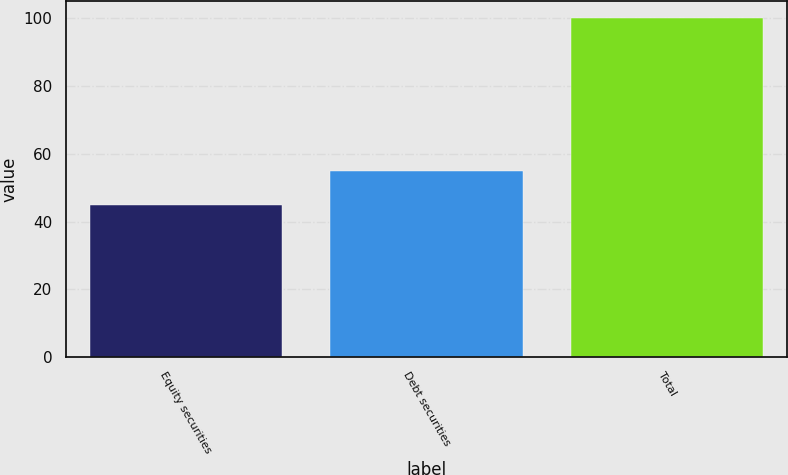<chart> <loc_0><loc_0><loc_500><loc_500><bar_chart><fcel>Equity securities<fcel>Debt securities<fcel>Total<nl><fcel>45<fcel>55<fcel>100<nl></chart> 